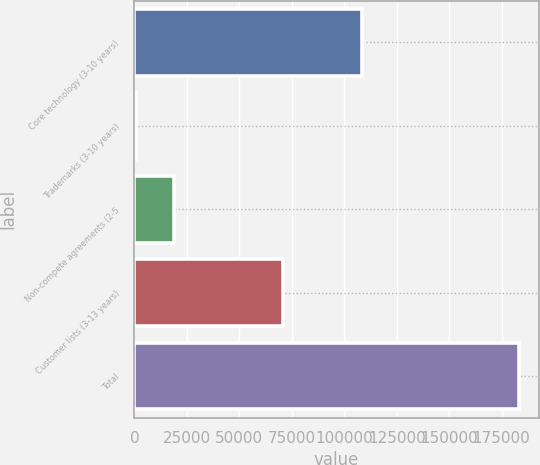Convert chart. <chart><loc_0><loc_0><loc_500><loc_500><bar_chart><fcel>Core technology (3-10 years)<fcel>Trademarks (3-10 years)<fcel>Non-compete agreements (2-5<fcel>Customer lists (3-13 years)<fcel>Total<nl><fcel>108329<fcel>510<fcel>18812.4<fcel>70902<fcel>183534<nl></chart> 